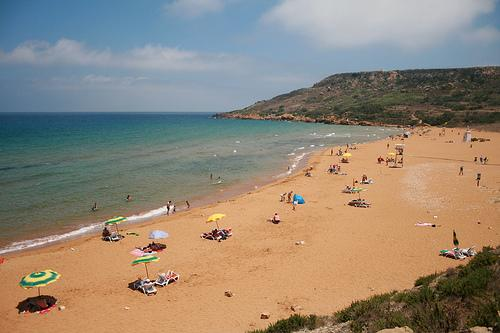Describe the landscape elements present in the image, including natural formations and colors. The image features a blue sky with a white cloud, a green hill with vegetation, a sandy brown beach, blue and green ocean, and white waves. Create an advertisement tagline that highlights key features of the beach depicted in the image. "Paradise found: endless blue skies, gentle waves, and relaxation under colorful umbrellas await you on our sunny shores!" List down the objects in the image related to leisure and relaxation on the beach. Objects include white chairs, three colorful beach umbrellas, a lifeguard tower in the sand, and two lounge chairs with a closed umbrella in between. Mention the interaction between humans and the surroundings in the image in a single phrase. People are enjoying the beach, playing in the water, and relaxing under umbrellas on a sunny day. Write a sentence describing the overall atmosphere of the beach scene. The beach is filled with people enjoying the sunny day, lounging under umbrellas, and playing in the calm, blue ocean waves. What's the dominant color of the sky, and what does the presence of a particular weather element imply? The dominant color of the sky is blue, and the presence of a white cloud implies a clear, mostly cloudless day. In a few words, describe the condition of the ocean and the state of the waves. The ocean is calm, blue, and green, with small whitecap waves. Make a statement about the people in the scene who are interacting with the ocean. People are playing in the water, with one person watching over a toddler at the water's edge and two others further in the ocean. Complete this sentence: "A unique aspect of the landscape featured in the image is the _____ and _____." A unique aspect of the landscape featured in the image is the green hill beside the beach and the distant plateau against a cloudy blue sky. 